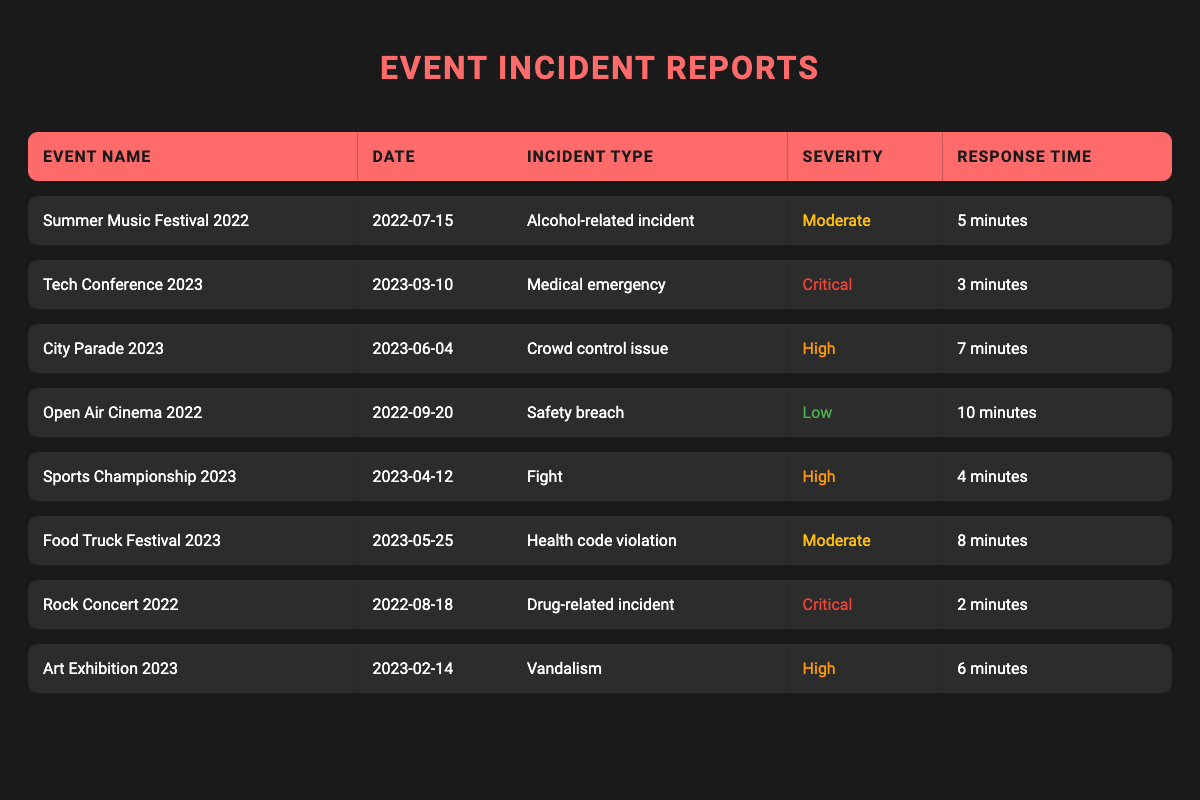What was the incident type at the Summer Music Festival 2022? Referring to the table, the incident type for the Summer Music Festival 2022 is listed as "Alcohol-related incident."
Answer: Alcohol-related incident Which event had the fastest response time? Looking at the response times in the table, the Rock Concert 2022 had the shortest response time at 2 minutes compared to others.
Answer: 2 minutes How many incidents reported had a severity rating of "High"? By counting the entries in the table, there are three incidents with a severity rating of "High": City Parade 2023, Sports Championship 2023, and Art Exhibition 2023.
Answer: 3 What is the average response time for incidents reported in 2023? To calculate the average response time, we sum the response times of incidents reported in 2023 (3 + 7 + 4 + 8 = 22) and divide by the number of incidents (4), giving an average of 22/4 = 5.5 minutes.
Answer: 5.5 minutes Did any incidents reported relate to health code violations? Checking the table, there is one entry that indicates a health code violation, which occurred at the Food Truck Festival 2023.
Answer: Yes Which incident had the longest response time, and what was that time? Scanning through the table, the Open Air Cinema 2022 incident had the longest response time of 10 minutes.
Answer: 10 minutes In total, how many incidents listed were reported by security staff? There is only one incident reported by security staff, which is the Summer Music Festival 2022.
Answer: 1 What is the difference between the highest and lowest severity ratings in the table? The highest severity rating is "Critical" (2 incidents), and the lowest is "Low" (1 incident). If we consider severity levels as numerical values (Critical = 4, High = 3, Moderate = 2, Low = 1), the difference is 4 - 1 = 3.
Answer: 3 Which event reported more than one type of serious incident in 2022? The data shows two serious incidents in 2022: Alcohol-related at Summer Music Festival and Drug-related at Rock Concert. Hence, 'Yes' applies to both of these events.
Answer: Yes What is the total number of incidents related to crowd control across all events? Referring to the table, there is one incident regarding crowd control, which is the City Parade 2023.
Answer: 1 